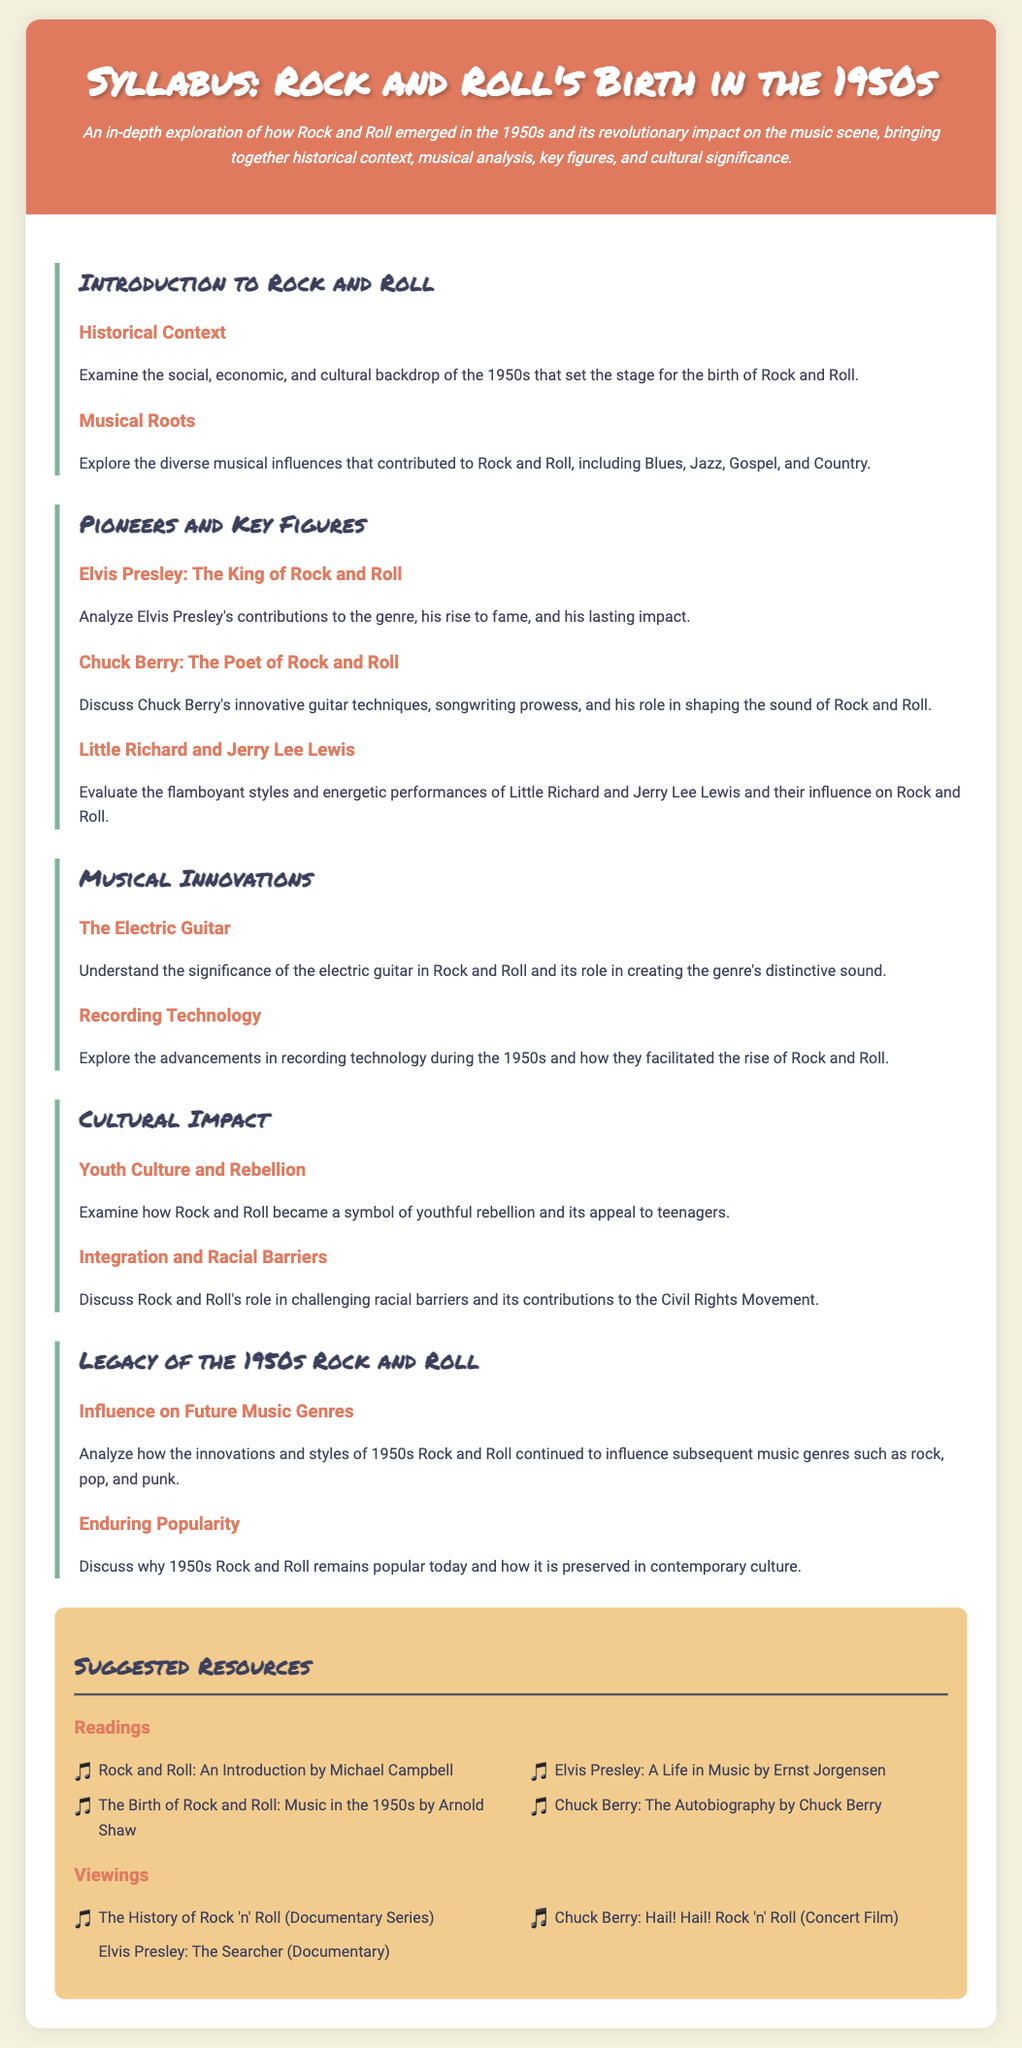What is the title of the syllabus? The title of the syllabus is prominently displayed at the top of the document.
Answer: Syllabus: Rock and Roll's Birth in the 1950s Who is referred to as the King of Rock and Roll? Elvis Presley's section mentions his title within the context of the genre.
Answer: Elvis Presley What musical innovations are discussed in the syllabus? The section on musical innovations highlights specific elements that contributed to Rock and Roll's sound.
Answer: The Electric Guitar, Recording Technology What is one suggested reading resource? The resources section includes a list of readings pertinent to the study of Rock and Roll.
Answer: Rock and Roll: An Introduction by Michael Campbell Which cultural impact is related to youth culture? The document discusses how Rock and Roll's image relates to the youth of the 1950s.
Answer: Youth Culture and Rebellion What does the syllabus describe as Rock and Roll's impact on racial barriers? This aspect is specifically highlighted in the cultural impact section of the syllabus.
Answer: Integration and Racial Barriers Who are two key figures mentioned alongside Elvis Presley? The syllabus discusses multiple pioneers in Rock and Roll, mentioning specific individuals.
Answer: Chuck Berry, Little Richard In what decade did Rock and Roll emerge according to the syllabus? The introductory context specifies the time frame for the birth of the genre.
Answer: 1950s What documentary series is included in the suggested viewings? The resources section lists films and documentaries relevant to the genre's history.
Answer: The History of Rock 'n' Roll 